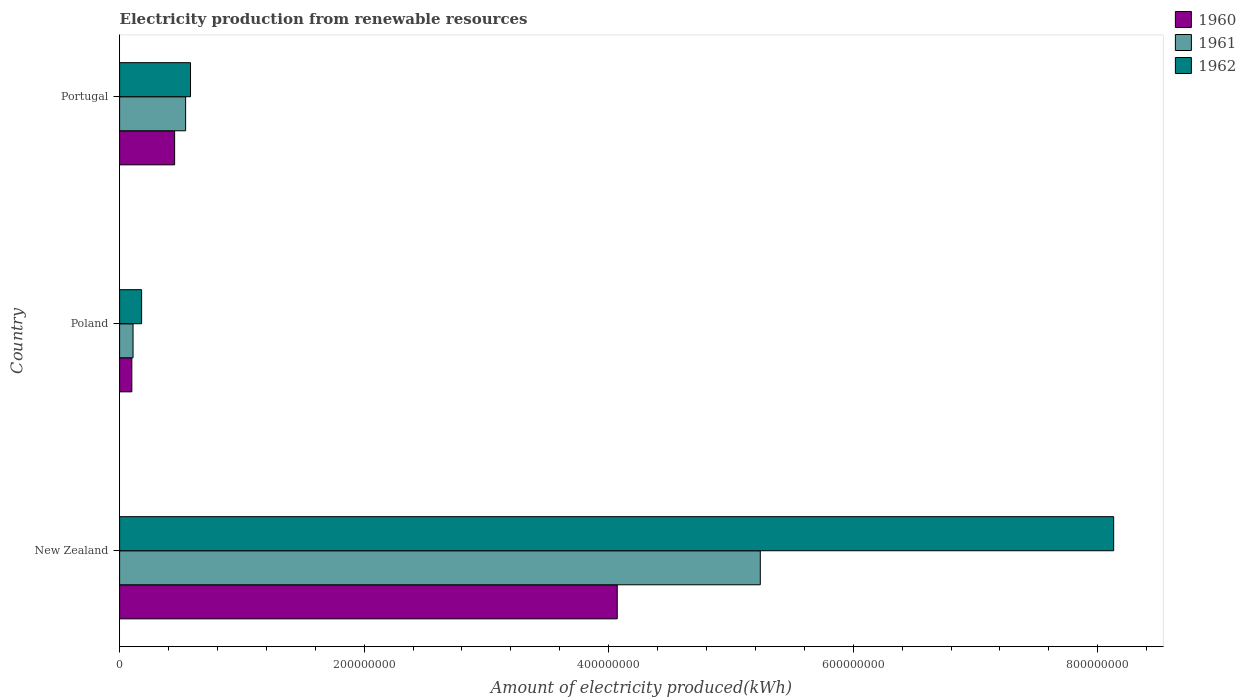How many groups of bars are there?
Provide a short and direct response. 3. What is the label of the 3rd group of bars from the top?
Keep it short and to the point. New Zealand. In how many cases, is the number of bars for a given country not equal to the number of legend labels?
Provide a short and direct response. 0. What is the amount of electricity produced in 1960 in Portugal?
Offer a terse response. 4.50e+07. Across all countries, what is the maximum amount of electricity produced in 1961?
Make the answer very short. 5.24e+08. Across all countries, what is the minimum amount of electricity produced in 1961?
Keep it short and to the point. 1.10e+07. In which country was the amount of electricity produced in 1962 maximum?
Offer a terse response. New Zealand. In which country was the amount of electricity produced in 1961 minimum?
Your response must be concise. Poland. What is the total amount of electricity produced in 1960 in the graph?
Keep it short and to the point. 4.62e+08. What is the difference between the amount of electricity produced in 1960 in New Zealand and that in Portugal?
Your response must be concise. 3.62e+08. What is the difference between the amount of electricity produced in 1962 in Poland and the amount of electricity produced in 1961 in Portugal?
Keep it short and to the point. -3.60e+07. What is the average amount of electricity produced in 1961 per country?
Provide a short and direct response. 1.96e+08. What is the ratio of the amount of electricity produced in 1962 in New Zealand to that in Poland?
Offer a terse response. 45.17. What is the difference between the highest and the second highest amount of electricity produced in 1962?
Offer a terse response. 7.55e+08. What is the difference between the highest and the lowest amount of electricity produced in 1961?
Offer a very short reply. 5.13e+08. What does the 3rd bar from the top in Portugal represents?
Offer a very short reply. 1960. What does the 2nd bar from the bottom in Poland represents?
Make the answer very short. 1961. Is it the case that in every country, the sum of the amount of electricity produced in 1961 and amount of electricity produced in 1962 is greater than the amount of electricity produced in 1960?
Your response must be concise. Yes. How many bars are there?
Make the answer very short. 9. Are all the bars in the graph horizontal?
Make the answer very short. Yes. How many countries are there in the graph?
Your answer should be compact. 3. Are the values on the major ticks of X-axis written in scientific E-notation?
Ensure brevity in your answer.  No. Does the graph contain any zero values?
Offer a very short reply. No. Does the graph contain grids?
Offer a very short reply. No. Where does the legend appear in the graph?
Give a very brief answer. Top right. What is the title of the graph?
Your response must be concise. Electricity production from renewable resources. Does "1976" appear as one of the legend labels in the graph?
Ensure brevity in your answer.  No. What is the label or title of the X-axis?
Provide a succinct answer. Amount of electricity produced(kWh). What is the label or title of the Y-axis?
Offer a very short reply. Country. What is the Amount of electricity produced(kWh) in 1960 in New Zealand?
Ensure brevity in your answer.  4.07e+08. What is the Amount of electricity produced(kWh) of 1961 in New Zealand?
Keep it short and to the point. 5.24e+08. What is the Amount of electricity produced(kWh) in 1962 in New Zealand?
Offer a very short reply. 8.13e+08. What is the Amount of electricity produced(kWh) of 1960 in Poland?
Your answer should be compact. 1.00e+07. What is the Amount of electricity produced(kWh) of 1961 in Poland?
Your response must be concise. 1.10e+07. What is the Amount of electricity produced(kWh) of 1962 in Poland?
Provide a short and direct response. 1.80e+07. What is the Amount of electricity produced(kWh) in 1960 in Portugal?
Your answer should be very brief. 4.50e+07. What is the Amount of electricity produced(kWh) in 1961 in Portugal?
Make the answer very short. 5.40e+07. What is the Amount of electricity produced(kWh) of 1962 in Portugal?
Your answer should be compact. 5.80e+07. Across all countries, what is the maximum Amount of electricity produced(kWh) in 1960?
Ensure brevity in your answer.  4.07e+08. Across all countries, what is the maximum Amount of electricity produced(kWh) in 1961?
Your response must be concise. 5.24e+08. Across all countries, what is the maximum Amount of electricity produced(kWh) in 1962?
Make the answer very short. 8.13e+08. Across all countries, what is the minimum Amount of electricity produced(kWh) in 1961?
Keep it short and to the point. 1.10e+07. Across all countries, what is the minimum Amount of electricity produced(kWh) of 1962?
Offer a very short reply. 1.80e+07. What is the total Amount of electricity produced(kWh) in 1960 in the graph?
Provide a succinct answer. 4.62e+08. What is the total Amount of electricity produced(kWh) in 1961 in the graph?
Make the answer very short. 5.89e+08. What is the total Amount of electricity produced(kWh) in 1962 in the graph?
Give a very brief answer. 8.89e+08. What is the difference between the Amount of electricity produced(kWh) in 1960 in New Zealand and that in Poland?
Provide a short and direct response. 3.97e+08. What is the difference between the Amount of electricity produced(kWh) of 1961 in New Zealand and that in Poland?
Your answer should be compact. 5.13e+08. What is the difference between the Amount of electricity produced(kWh) of 1962 in New Zealand and that in Poland?
Your answer should be very brief. 7.95e+08. What is the difference between the Amount of electricity produced(kWh) in 1960 in New Zealand and that in Portugal?
Give a very brief answer. 3.62e+08. What is the difference between the Amount of electricity produced(kWh) in 1961 in New Zealand and that in Portugal?
Offer a terse response. 4.70e+08. What is the difference between the Amount of electricity produced(kWh) in 1962 in New Zealand and that in Portugal?
Offer a very short reply. 7.55e+08. What is the difference between the Amount of electricity produced(kWh) of 1960 in Poland and that in Portugal?
Your answer should be compact. -3.50e+07. What is the difference between the Amount of electricity produced(kWh) in 1961 in Poland and that in Portugal?
Ensure brevity in your answer.  -4.30e+07. What is the difference between the Amount of electricity produced(kWh) of 1962 in Poland and that in Portugal?
Offer a terse response. -4.00e+07. What is the difference between the Amount of electricity produced(kWh) in 1960 in New Zealand and the Amount of electricity produced(kWh) in 1961 in Poland?
Provide a short and direct response. 3.96e+08. What is the difference between the Amount of electricity produced(kWh) of 1960 in New Zealand and the Amount of electricity produced(kWh) of 1962 in Poland?
Offer a very short reply. 3.89e+08. What is the difference between the Amount of electricity produced(kWh) in 1961 in New Zealand and the Amount of electricity produced(kWh) in 1962 in Poland?
Offer a very short reply. 5.06e+08. What is the difference between the Amount of electricity produced(kWh) in 1960 in New Zealand and the Amount of electricity produced(kWh) in 1961 in Portugal?
Keep it short and to the point. 3.53e+08. What is the difference between the Amount of electricity produced(kWh) in 1960 in New Zealand and the Amount of electricity produced(kWh) in 1962 in Portugal?
Offer a terse response. 3.49e+08. What is the difference between the Amount of electricity produced(kWh) in 1961 in New Zealand and the Amount of electricity produced(kWh) in 1962 in Portugal?
Give a very brief answer. 4.66e+08. What is the difference between the Amount of electricity produced(kWh) of 1960 in Poland and the Amount of electricity produced(kWh) of 1961 in Portugal?
Your answer should be very brief. -4.40e+07. What is the difference between the Amount of electricity produced(kWh) in 1960 in Poland and the Amount of electricity produced(kWh) in 1962 in Portugal?
Your answer should be compact. -4.80e+07. What is the difference between the Amount of electricity produced(kWh) of 1961 in Poland and the Amount of electricity produced(kWh) of 1962 in Portugal?
Give a very brief answer. -4.70e+07. What is the average Amount of electricity produced(kWh) in 1960 per country?
Your answer should be compact. 1.54e+08. What is the average Amount of electricity produced(kWh) in 1961 per country?
Your response must be concise. 1.96e+08. What is the average Amount of electricity produced(kWh) in 1962 per country?
Keep it short and to the point. 2.96e+08. What is the difference between the Amount of electricity produced(kWh) of 1960 and Amount of electricity produced(kWh) of 1961 in New Zealand?
Offer a very short reply. -1.17e+08. What is the difference between the Amount of electricity produced(kWh) of 1960 and Amount of electricity produced(kWh) of 1962 in New Zealand?
Provide a short and direct response. -4.06e+08. What is the difference between the Amount of electricity produced(kWh) in 1961 and Amount of electricity produced(kWh) in 1962 in New Zealand?
Give a very brief answer. -2.89e+08. What is the difference between the Amount of electricity produced(kWh) of 1960 and Amount of electricity produced(kWh) of 1962 in Poland?
Provide a short and direct response. -8.00e+06. What is the difference between the Amount of electricity produced(kWh) in 1961 and Amount of electricity produced(kWh) in 1962 in Poland?
Ensure brevity in your answer.  -7.00e+06. What is the difference between the Amount of electricity produced(kWh) in 1960 and Amount of electricity produced(kWh) in 1961 in Portugal?
Your answer should be compact. -9.00e+06. What is the difference between the Amount of electricity produced(kWh) of 1960 and Amount of electricity produced(kWh) of 1962 in Portugal?
Offer a very short reply. -1.30e+07. What is the difference between the Amount of electricity produced(kWh) of 1961 and Amount of electricity produced(kWh) of 1962 in Portugal?
Give a very brief answer. -4.00e+06. What is the ratio of the Amount of electricity produced(kWh) in 1960 in New Zealand to that in Poland?
Offer a very short reply. 40.7. What is the ratio of the Amount of electricity produced(kWh) of 1961 in New Zealand to that in Poland?
Offer a very short reply. 47.64. What is the ratio of the Amount of electricity produced(kWh) of 1962 in New Zealand to that in Poland?
Provide a succinct answer. 45.17. What is the ratio of the Amount of electricity produced(kWh) in 1960 in New Zealand to that in Portugal?
Give a very brief answer. 9.04. What is the ratio of the Amount of electricity produced(kWh) of 1961 in New Zealand to that in Portugal?
Offer a very short reply. 9.7. What is the ratio of the Amount of electricity produced(kWh) in 1962 in New Zealand to that in Portugal?
Offer a very short reply. 14.02. What is the ratio of the Amount of electricity produced(kWh) of 1960 in Poland to that in Portugal?
Provide a short and direct response. 0.22. What is the ratio of the Amount of electricity produced(kWh) of 1961 in Poland to that in Portugal?
Provide a succinct answer. 0.2. What is the ratio of the Amount of electricity produced(kWh) of 1962 in Poland to that in Portugal?
Provide a short and direct response. 0.31. What is the difference between the highest and the second highest Amount of electricity produced(kWh) in 1960?
Give a very brief answer. 3.62e+08. What is the difference between the highest and the second highest Amount of electricity produced(kWh) of 1961?
Your response must be concise. 4.70e+08. What is the difference between the highest and the second highest Amount of electricity produced(kWh) of 1962?
Make the answer very short. 7.55e+08. What is the difference between the highest and the lowest Amount of electricity produced(kWh) of 1960?
Provide a succinct answer. 3.97e+08. What is the difference between the highest and the lowest Amount of electricity produced(kWh) of 1961?
Keep it short and to the point. 5.13e+08. What is the difference between the highest and the lowest Amount of electricity produced(kWh) of 1962?
Your answer should be very brief. 7.95e+08. 